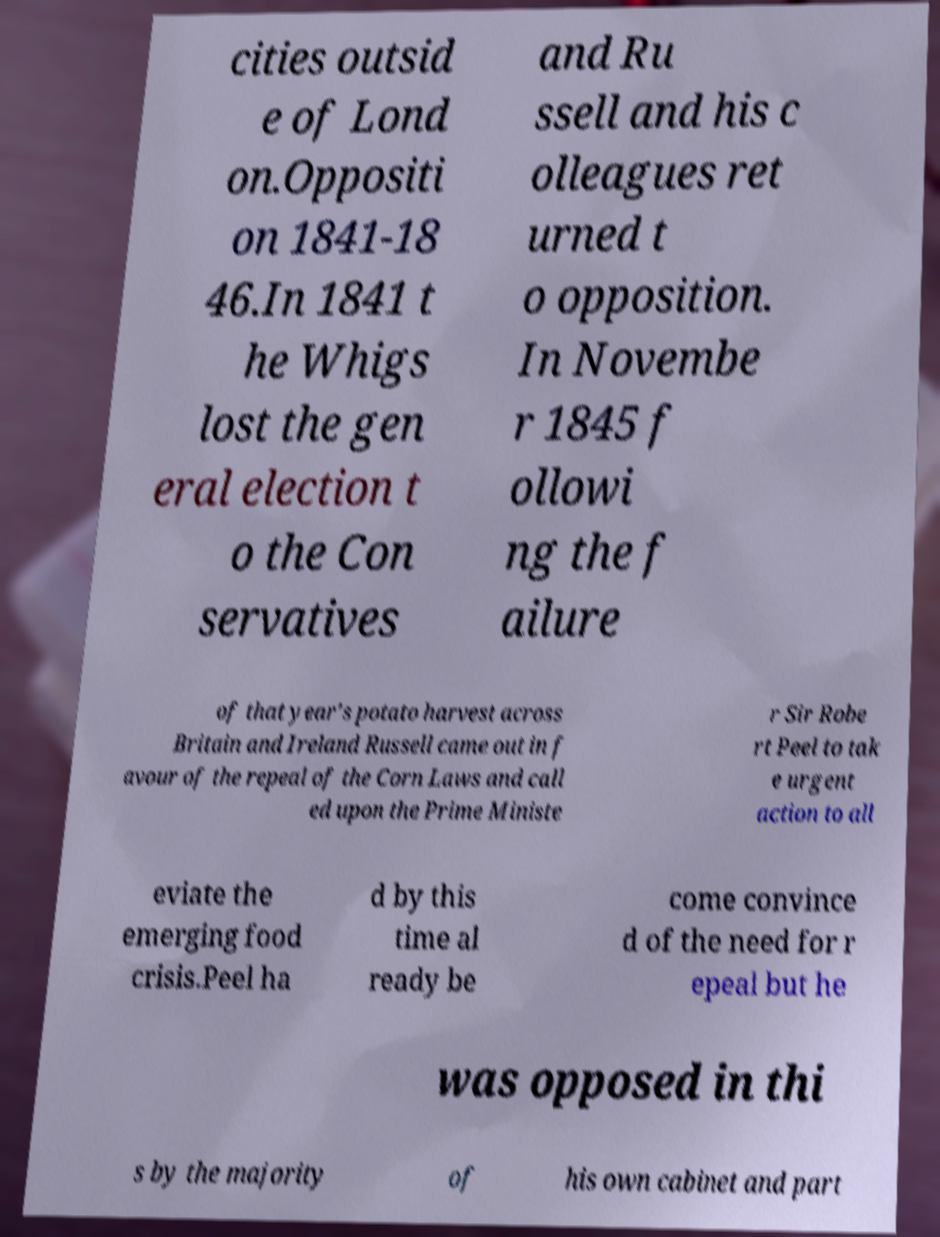Please read and relay the text visible in this image. What does it say? cities outsid e of Lond on.Oppositi on 1841-18 46.In 1841 t he Whigs lost the gen eral election t o the Con servatives and Ru ssell and his c olleagues ret urned t o opposition. In Novembe r 1845 f ollowi ng the f ailure of that year's potato harvest across Britain and Ireland Russell came out in f avour of the repeal of the Corn Laws and call ed upon the Prime Ministe r Sir Robe rt Peel to tak e urgent action to all eviate the emerging food crisis.Peel ha d by this time al ready be come convince d of the need for r epeal but he was opposed in thi s by the majority of his own cabinet and part 